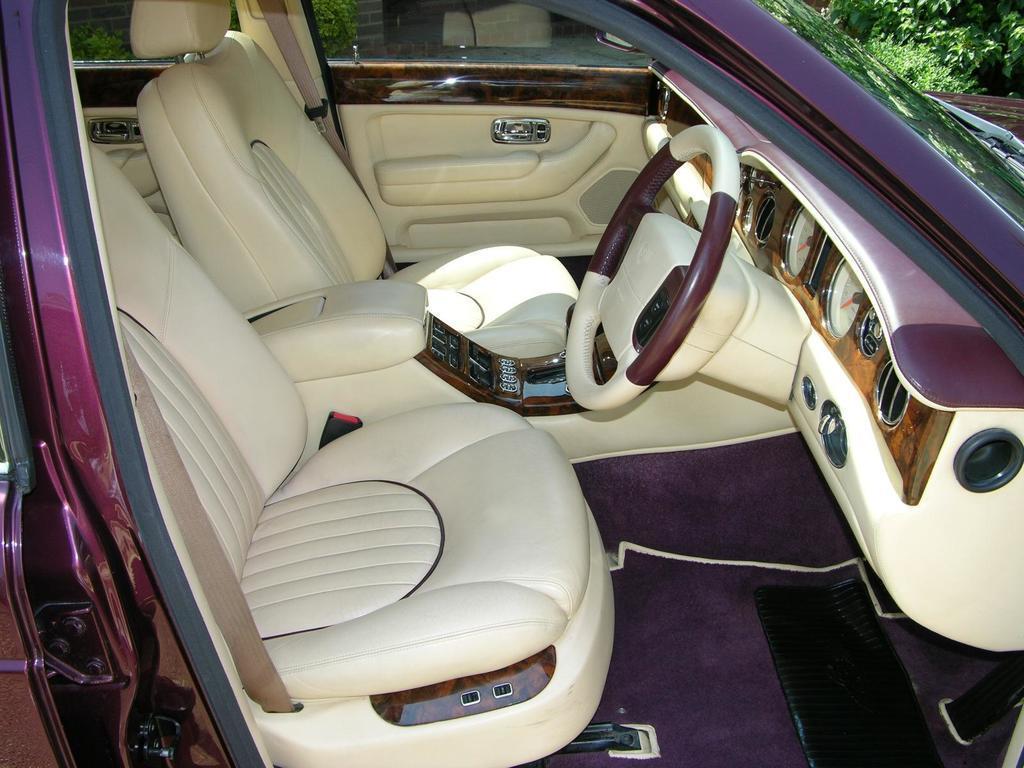In one or two sentences, can you explain what this image depicts? In the foreground of this image, there is a purple car, where we can see two seats, a steering, mat, meters and the door. On the right top, there is the greenery. 